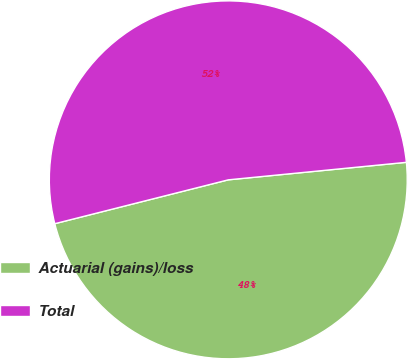Convert chart. <chart><loc_0><loc_0><loc_500><loc_500><pie_chart><fcel>Actuarial (gains)/loss<fcel>Total<nl><fcel>47.62%<fcel>52.38%<nl></chart> 